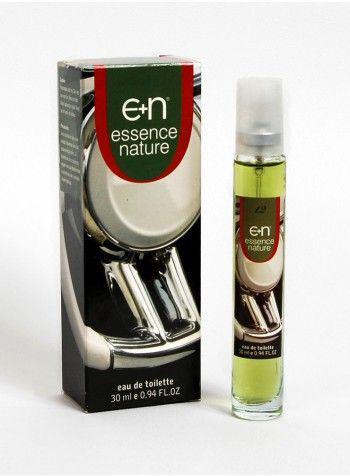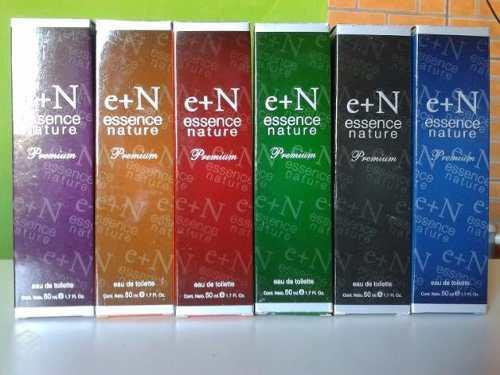The first image is the image on the left, the second image is the image on the right. For the images displayed, is the sentence "In one image, a single slender spray bottle stands to the left of a box with a woman's face on it." factually correct? Answer yes or no. No. The first image is the image on the left, the second image is the image on the right. Assess this claim about the two images: "The right image contains one slim cylinder perfume bottle that is to the left of its packaging case.". Correct or not? Answer yes or no. No. 